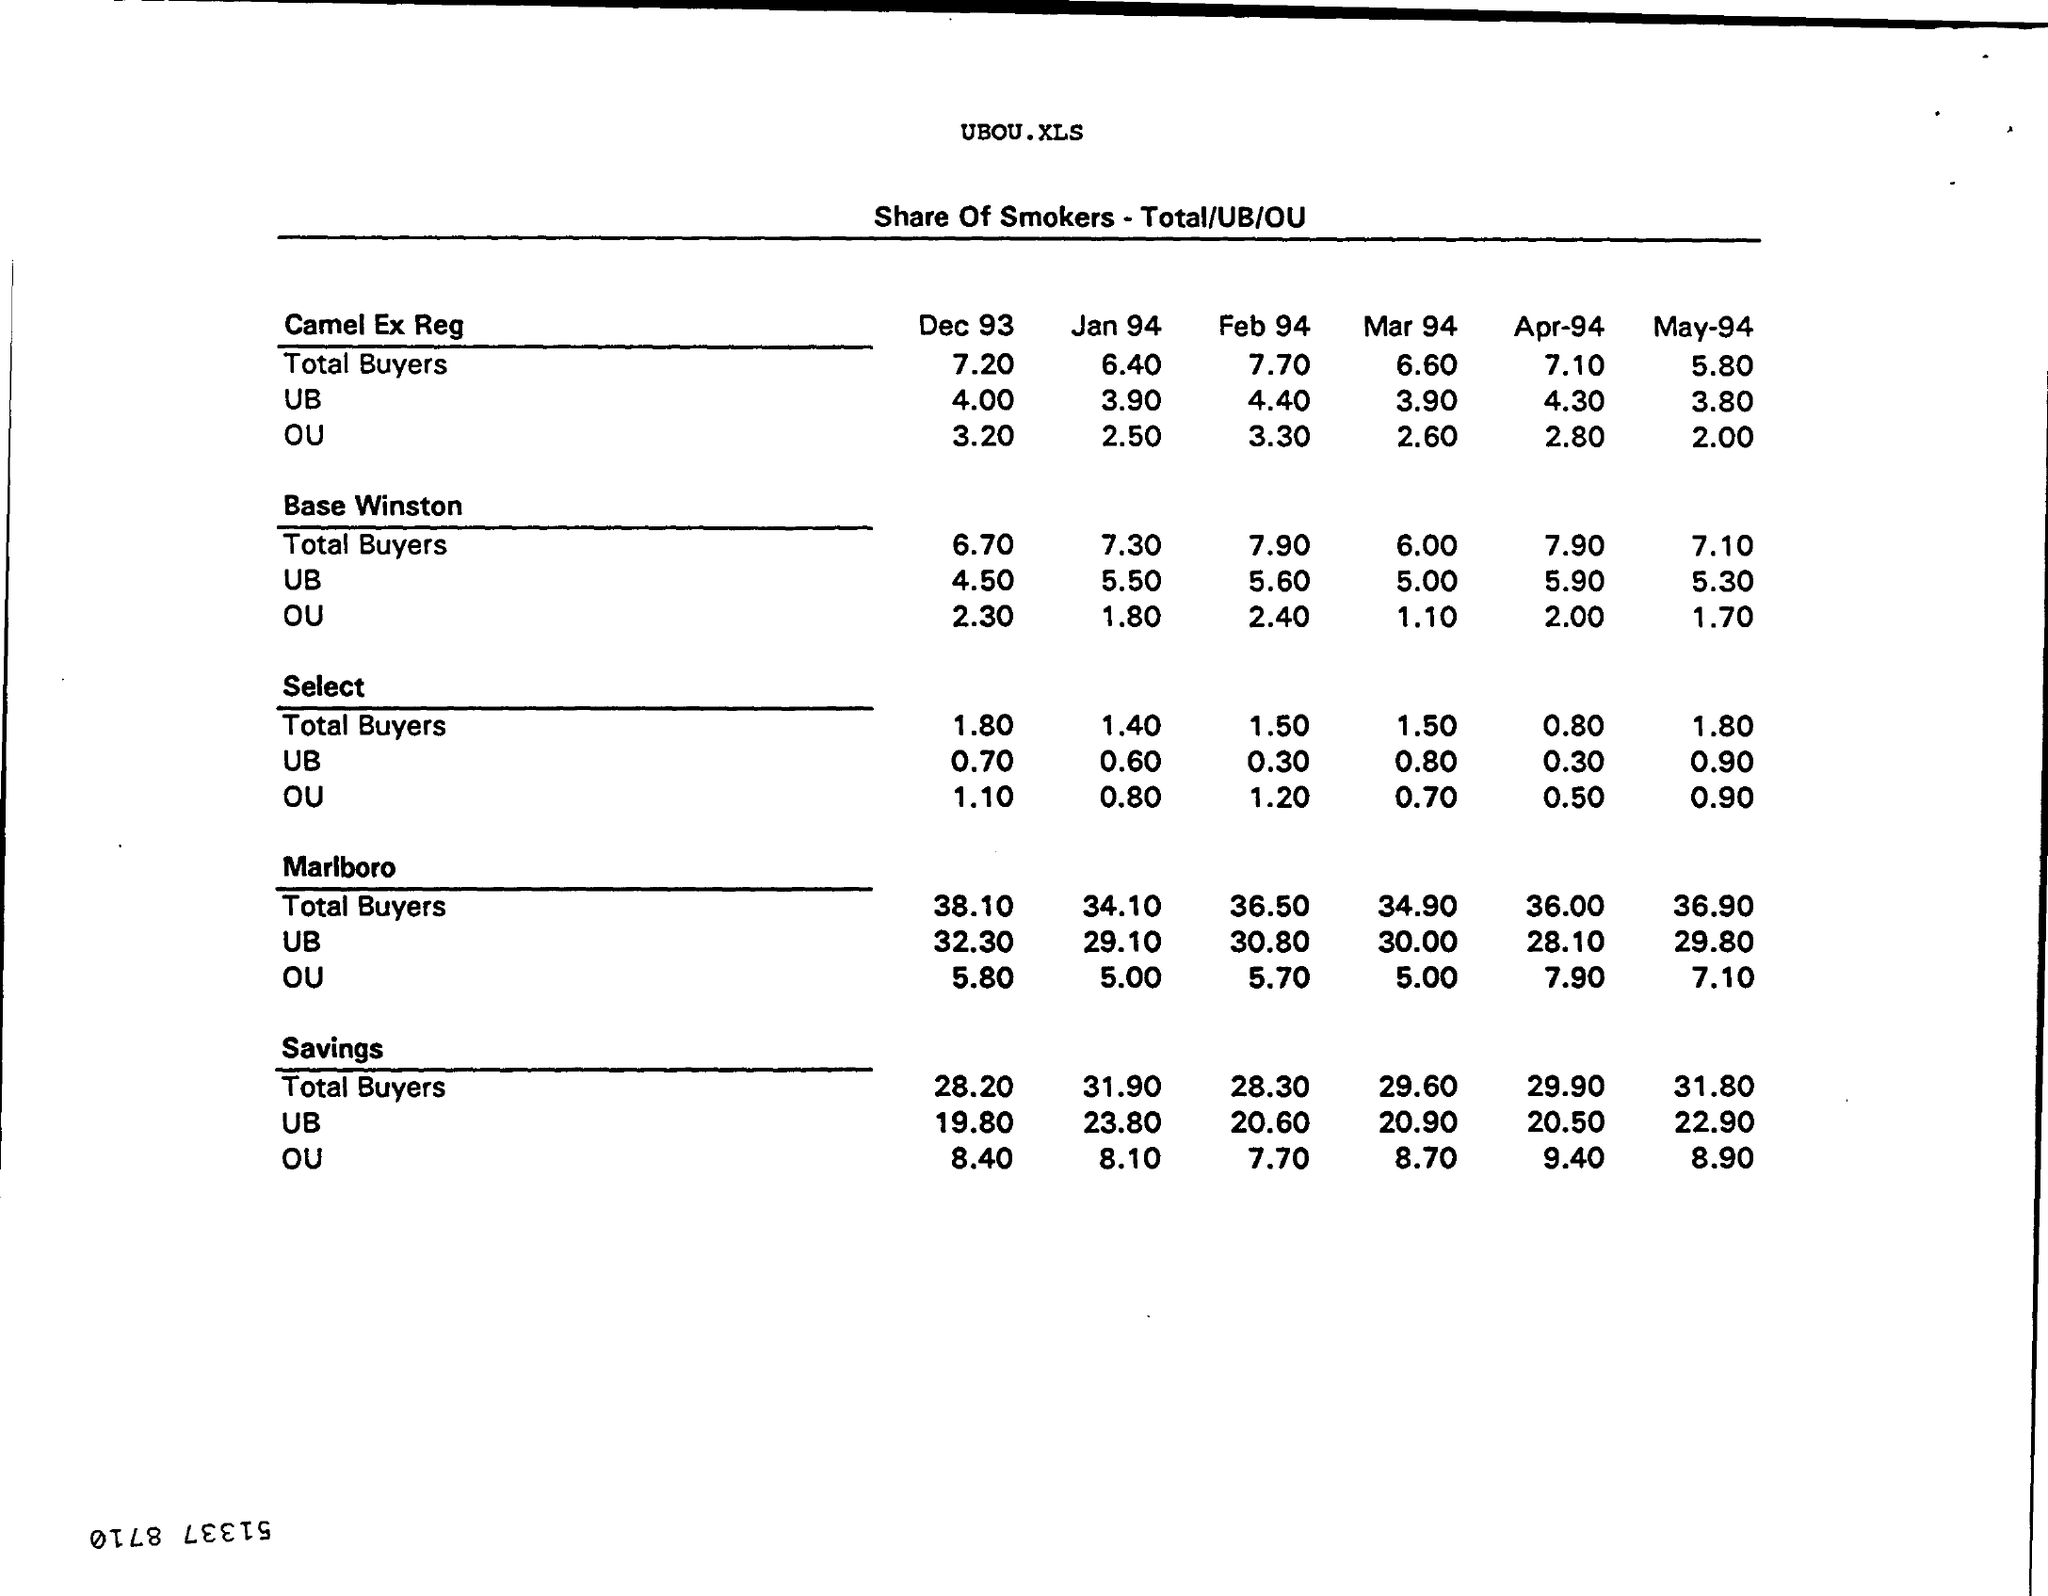What is the Total Buyers for Camel Ex Reg for Dec 93?
Offer a terse response. 7.20. What is the UB for Camel Ex Reg for Dec 93?
Keep it short and to the point. 4.00. What is the OU for Camel Ex Reg for Dec 93?
Keep it short and to the point. 3.20. What is the Total Buyers for Base Winston for Dec 93?
Your answer should be compact. 6.70. What is the UB for Base Winston for Dec 93?
Ensure brevity in your answer.  4.50. What is the OU for Base Winston for Dec 93?
Ensure brevity in your answer.  2.30. What is the Total Buyers for Select for Dec 93?
Offer a terse response. 1.80. What is the UB for Select for Dec 93?
Provide a succinct answer. 0.70. What is the OU for Select for Dec 93?
Give a very brief answer. 1.10. What is the Total Buyers for Marlboro for Jan 94?
Make the answer very short. 34.10. 